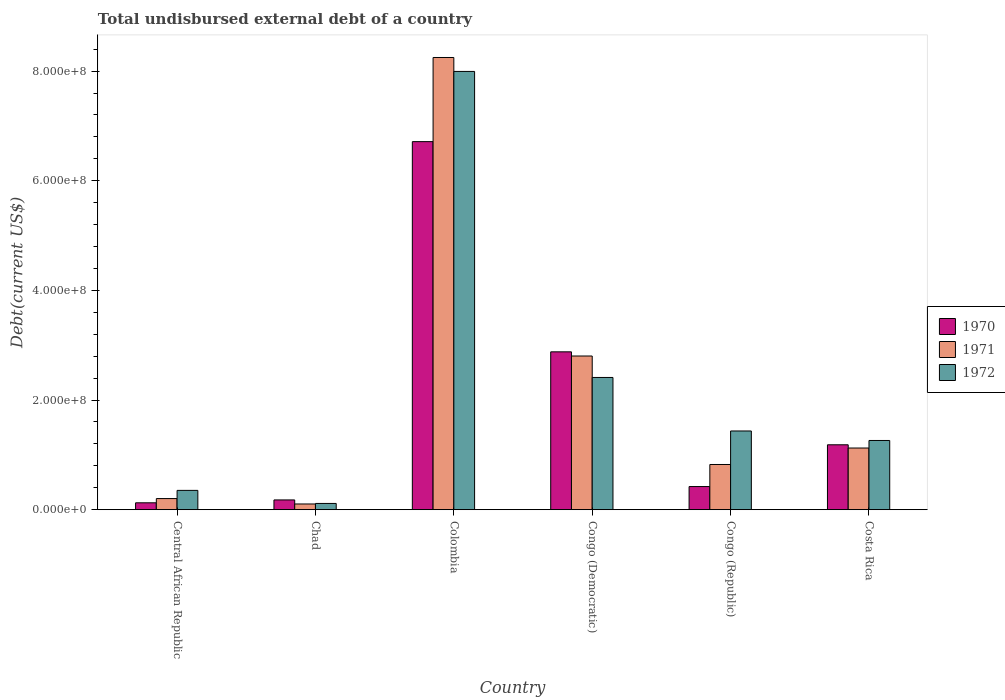Are the number of bars per tick equal to the number of legend labels?
Give a very brief answer. Yes. Are the number of bars on each tick of the X-axis equal?
Your response must be concise. Yes. How many bars are there on the 6th tick from the left?
Your answer should be very brief. 3. How many bars are there on the 6th tick from the right?
Offer a very short reply. 3. What is the label of the 5th group of bars from the left?
Provide a short and direct response. Congo (Republic). In how many cases, is the number of bars for a given country not equal to the number of legend labels?
Keep it short and to the point. 0. What is the total undisbursed external debt in 1972 in Congo (Democratic)?
Provide a succinct answer. 2.41e+08. Across all countries, what is the maximum total undisbursed external debt in 1970?
Ensure brevity in your answer.  6.71e+08. Across all countries, what is the minimum total undisbursed external debt in 1972?
Give a very brief answer. 1.14e+07. In which country was the total undisbursed external debt in 1972 maximum?
Offer a terse response. Colombia. In which country was the total undisbursed external debt in 1971 minimum?
Keep it short and to the point. Chad. What is the total total undisbursed external debt in 1970 in the graph?
Provide a short and direct response. 1.15e+09. What is the difference between the total undisbursed external debt in 1972 in Central African Republic and that in Chad?
Give a very brief answer. 2.38e+07. What is the difference between the total undisbursed external debt in 1972 in Congo (Democratic) and the total undisbursed external debt in 1970 in Costa Rica?
Make the answer very short. 1.23e+08. What is the average total undisbursed external debt in 1971 per country?
Make the answer very short. 2.22e+08. What is the difference between the total undisbursed external debt of/in 1971 and total undisbursed external debt of/in 1972 in Costa Rica?
Ensure brevity in your answer.  -1.38e+07. What is the ratio of the total undisbursed external debt in 1970 in Congo (Republic) to that in Costa Rica?
Your answer should be very brief. 0.36. Is the total undisbursed external debt in 1972 in Central African Republic less than that in Colombia?
Offer a terse response. Yes. Is the difference between the total undisbursed external debt in 1971 in Central African Republic and Congo (Republic) greater than the difference between the total undisbursed external debt in 1972 in Central African Republic and Congo (Republic)?
Make the answer very short. Yes. What is the difference between the highest and the second highest total undisbursed external debt in 1971?
Make the answer very short. 7.12e+08. What is the difference between the highest and the lowest total undisbursed external debt in 1971?
Ensure brevity in your answer.  8.14e+08. How many bars are there?
Make the answer very short. 18. Are all the bars in the graph horizontal?
Your answer should be compact. No. Does the graph contain grids?
Your answer should be compact. No. How many legend labels are there?
Your response must be concise. 3. How are the legend labels stacked?
Offer a terse response. Vertical. What is the title of the graph?
Your answer should be compact. Total undisbursed external debt of a country. What is the label or title of the Y-axis?
Ensure brevity in your answer.  Debt(current US$). What is the Debt(current US$) of 1970 in Central African Republic?
Ensure brevity in your answer.  1.26e+07. What is the Debt(current US$) of 1971 in Central African Republic?
Keep it short and to the point. 2.03e+07. What is the Debt(current US$) of 1972 in Central African Republic?
Provide a succinct answer. 3.52e+07. What is the Debt(current US$) of 1970 in Chad?
Give a very brief answer. 1.78e+07. What is the Debt(current US$) of 1971 in Chad?
Give a very brief answer. 1.04e+07. What is the Debt(current US$) in 1972 in Chad?
Your response must be concise. 1.14e+07. What is the Debt(current US$) in 1970 in Colombia?
Your answer should be compact. 6.71e+08. What is the Debt(current US$) of 1971 in Colombia?
Provide a short and direct response. 8.25e+08. What is the Debt(current US$) of 1972 in Colombia?
Provide a succinct answer. 7.99e+08. What is the Debt(current US$) of 1970 in Congo (Democratic)?
Offer a very short reply. 2.88e+08. What is the Debt(current US$) of 1971 in Congo (Democratic)?
Offer a terse response. 2.80e+08. What is the Debt(current US$) in 1972 in Congo (Democratic)?
Give a very brief answer. 2.41e+08. What is the Debt(current US$) of 1970 in Congo (Republic)?
Your answer should be compact. 4.22e+07. What is the Debt(current US$) of 1971 in Congo (Republic)?
Make the answer very short. 8.24e+07. What is the Debt(current US$) in 1972 in Congo (Republic)?
Ensure brevity in your answer.  1.44e+08. What is the Debt(current US$) in 1970 in Costa Rica?
Provide a short and direct response. 1.18e+08. What is the Debt(current US$) of 1971 in Costa Rica?
Provide a succinct answer. 1.12e+08. What is the Debt(current US$) of 1972 in Costa Rica?
Ensure brevity in your answer.  1.26e+08. Across all countries, what is the maximum Debt(current US$) in 1970?
Provide a succinct answer. 6.71e+08. Across all countries, what is the maximum Debt(current US$) of 1971?
Make the answer very short. 8.25e+08. Across all countries, what is the maximum Debt(current US$) in 1972?
Ensure brevity in your answer.  7.99e+08. Across all countries, what is the minimum Debt(current US$) of 1970?
Offer a terse response. 1.26e+07. Across all countries, what is the minimum Debt(current US$) in 1971?
Make the answer very short. 1.04e+07. Across all countries, what is the minimum Debt(current US$) in 1972?
Keep it short and to the point. 1.14e+07. What is the total Debt(current US$) in 1970 in the graph?
Make the answer very short. 1.15e+09. What is the total Debt(current US$) of 1971 in the graph?
Make the answer very short. 1.33e+09. What is the total Debt(current US$) of 1972 in the graph?
Ensure brevity in your answer.  1.36e+09. What is the difference between the Debt(current US$) in 1970 in Central African Republic and that in Chad?
Your response must be concise. -5.25e+06. What is the difference between the Debt(current US$) of 1971 in Central African Republic and that in Chad?
Make the answer very short. 9.88e+06. What is the difference between the Debt(current US$) of 1972 in Central African Republic and that in Chad?
Keep it short and to the point. 2.38e+07. What is the difference between the Debt(current US$) in 1970 in Central African Republic and that in Colombia?
Keep it short and to the point. -6.59e+08. What is the difference between the Debt(current US$) in 1971 in Central African Republic and that in Colombia?
Make the answer very short. -8.05e+08. What is the difference between the Debt(current US$) in 1972 in Central African Republic and that in Colombia?
Ensure brevity in your answer.  -7.64e+08. What is the difference between the Debt(current US$) in 1970 in Central African Republic and that in Congo (Democratic)?
Your response must be concise. -2.75e+08. What is the difference between the Debt(current US$) in 1971 in Central African Republic and that in Congo (Democratic)?
Offer a very short reply. -2.60e+08. What is the difference between the Debt(current US$) in 1972 in Central African Republic and that in Congo (Democratic)?
Make the answer very short. -2.06e+08. What is the difference between the Debt(current US$) in 1970 in Central African Republic and that in Congo (Republic)?
Offer a very short reply. -2.96e+07. What is the difference between the Debt(current US$) in 1971 in Central African Republic and that in Congo (Republic)?
Provide a succinct answer. -6.21e+07. What is the difference between the Debt(current US$) of 1972 in Central African Republic and that in Congo (Republic)?
Provide a succinct answer. -1.08e+08. What is the difference between the Debt(current US$) of 1970 in Central African Republic and that in Costa Rica?
Keep it short and to the point. -1.06e+08. What is the difference between the Debt(current US$) of 1971 in Central African Republic and that in Costa Rica?
Your answer should be compact. -9.22e+07. What is the difference between the Debt(current US$) of 1972 in Central African Republic and that in Costa Rica?
Provide a succinct answer. -9.10e+07. What is the difference between the Debt(current US$) of 1970 in Chad and that in Colombia?
Make the answer very short. -6.54e+08. What is the difference between the Debt(current US$) of 1971 in Chad and that in Colombia?
Give a very brief answer. -8.14e+08. What is the difference between the Debt(current US$) of 1972 in Chad and that in Colombia?
Offer a very short reply. -7.88e+08. What is the difference between the Debt(current US$) of 1970 in Chad and that in Congo (Democratic)?
Ensure brevity in your answer.  -2.70e+08. What is the difference between the Debt(current US$) of 1971 in Chad and that in Congo (Democratic)?
Provide a succinct answer. -2.70e+08. What is the difference between the Debt(current US$) in 1972 in Chad and that in Congo (Democratic)?
Offer a terse response. -2.30e+08. What is the difference between the Debt(current US$) in 1970 in Chad and that in Congo (Republic)?
Make the answer very short. -2.44e+07. What is the difference between the Debt(current US$) of 1971 in Chad and that in Congo (Republic)?
Provide a succinct answer. -7.20e+07. What is the difference between the Debt(current US$) of 1972 in Chad and that in Congo (Republic)?
Your answer should be very brief. -1.32e+08. What is the difference between the Debt(current US$) of 1970 in Chad and that in Costa Rica?
Ensure brevity in your answer.  -1.01e+08. What is the difference between the Debt(current US$) in 1971 in Chad and that in Costa Rica?
Provide a succinct answer. -1.02e+08. What is the difference between the Debt(current US$) in 1972 in Chad and that in Costa Rica?
Your answer should be very brief. -1.15e+08. What is the difference between the Debt(current US$) in 1970 in Colombia and that in Congo (Democratic)?
Your answer should be very brief. 3.83e+08. What is the difference between the Debt(current US$) of 1971 in Colombia and that in Congo (Democratic)?
Keep it short and to the point. 5.45e+08. What is the difference between the Debt(current US$) in 1972 in Colombia and that in Congo (Democratic)?
Your answer should be very brief. 5.58e+08. What is the difference between the Debt(current US$) of 1970 in Colombia and that in Congo (Republic)?
Provide a short and direct response. 6.29e+08. What is the difference between the Debt(current US$) in 1971 in Colombia and that in Congo (Republic)?
Ensure brevity in your answer.  7.42e+08. What is the difference between the Debt(current US$) in 1972 in Colombia and that in Congo (Republic)?
Ensure brevity in your answer.  6.56e+08. What is the difference between the Debt(current US$) of 1970 in Colombia and that in Costa Rica?
Your answer should be very brief. 5.53e+08. What is the difference between the Debt(current US$) of 1971 in Colombia and that in Costa Rica?
Ensure brevity in your answer.  7.12e+08. What is the difference between the Debt(current US$) in 1972 in Colombia and that in Costa Rica?
Offer a terse response. 6.73e+08. What is the difference between the Debt(current US$) in 1970 in Congo (Democratic) and that in Congo (Republic)?
Make the answer very short. 2.46e+08. What is the difference between the Debt(current US$) in 1971 in Congo (Democratic) and that in Congo (Republic)?
Your answer should be compact. 1.98e+08. What is the difference between the Debt(current US$) of 1972 in Congo (Democratic) and that in Congo (Republic)?
Your response must be concise. 9.76e+07. What is the difference between the Debt(current US$) in 1970 in Congo (Democratic) and that in Costa Rica?
Your answer should be very brief. 1.70e+08. What is the difference between the Debt(current US$) of 1971 in Congo (Democratic) and that in Costa Rica?
Make the answer very short. 1.68e+08. What is the difference between the Debt(current US$) of 1972 in Congo (Democratic) and that in Costa Rica?
Your answer should be compact. 1.15e+08. What is the difference between the Debt(current US$) of 1970 in Congo (Republic) and that in Costa Rica?
Your answer should be very brief. -7.62e+07. What is the difference between the Debt(current US$) in 1971 in Congo (Republic) and that in Costa Rica?
Your response must be concise. -3.00e+07. What is the difference between the Debt(current US$) in 1972 in Congo (Republic) and that in Costa Rica?
Keep it short and to the point. 1.73e+07. What is the difference between the Debt(current US$) in 1970 in Central African Republic and the Debt(current US$) in 1971 in Chad?
Offer a terse response. 2.13e+06. What is the difference between the Debt(current US$) in 1970 in Central African Republic and the Debt(current US$) in 1972 in Chad?
Give a very brief answer. 1.15e+06. What is the difference between the Debt(current US$) of 1971 in Central African Republic and the Debt(current US$) of 1972 in Chad?
Offer a very short reply. 8.90e+06. What is the difference between the Debt(current US$) in 1970 in Central African Republic and the Debt(current US$) in 1971 in Colombia?
Provide a succinct answer. -8.12e+08. What is the difference between the Debt(current US$) of 1970 in Central African Republic and the Debt(current US$) of 1972 in Colombia?
Provide a short and direct response. -7.87e+08. What is the difference between the Debt(current US$) of 1971 in Central African Republic and the Debt(current US$) of 1972 in Colombia?
Give a very brief answer. -7.79e+08. What is the difference between the Debt(current US$) in 1970 in Central African Republic and the Debt(current US$) in 1971 in Congo (Democratic)?
Keep it short and to the point. -2.68e+08. What is the difference between the Debt(current US$) in 1970 in Central African Republic and the Debt(current US$) in 1972 in Congo (Democratic)?
Your answer should be compact. -2.29e+08. What is the difference between the Debt(current US$) in 1971 in Central African Republic and the Debt(current US$) in 1972 in Congo (Democratic)?
Provide a short and direct response. -2.21e+08. What is the difference between the Debt(current US$) in 1970 in Central African Republic and the Debt(current US$) in 1971 in Congo (Republic)?
Your response must be concise. -6.99e+07. What is the difference between the Debt(current US$) in 1970 in Central African Republic and the Debt(current US$) in 1972 in Congo (Republic)?
Keep it short and to the point. -1.31e+08. What is the difference between the Debt(current US$) in 1971 in Central African Republic and the Debt(current US$) in 1972 in Congo (Republic)?
Keep it short and to the point. -1.23e+08. What is the difference between the Debt(current US$) of 1970 in Central African Republic and the Debt(current US$) of 1971 in Costa Rica?
Offer a very short reply. -9.99e+07. What is the difference between the Debt(current US$) in 1970 in Central African Republic and the Debt(current US$) in 1972 in Costa Rica?
Give a very brief answer. -1.14e+08. What is the difference between the Debt(current US$) of 1971 in Central African Republic and the Debt(current US$) of 1972 in Costa Rica?
Your answer should be very brief. -1.06e+08. What is the difference between the Debt(current US$) of 1970 in Chad and the Debt(current US$) of 1971 in Colombia?
Give a very brief answer. -8.07e+08. What is the difference between the Debt(current US$) of 1970 in Chad and the Debt(current US$) of 1972 in Colombia?
Give a very brief answer. -7.82e+08. What is the difference between the Debt(current US$) of 1971 in Chad and the Debt(current US$) of 1972 in Colombia?
Offer a terse response. -7.89e+08. What is the difference between the Debt(current US$) in 1970 in Chad and the Debt(current US$) in 1971 in Congo (Democratic)?
Ensure brevity in your answer.  -2.63e+08. What is the difference between the Debt(current US$) of 1970 in Chad and the Debt(current US$) of 1972 in Congo (Democratic)?
Keep it short and to the point. -2.23e+08. What is the difference between the Debt(current US$) in 1971 in Chad and the Debt(current US$) in 1972 in Congo (Democratic)?
Make the answer very short. -2.31e+08. What is the difference between the Debt(current US$) in 1970 in Chad and the Debt(current US$) in 1971 in Congo (Republic)?
Provide a short and direct response. -6.46e+07. What is the difference between the Debt(current US$) of 1970 in Chad and the Debt(current US$) of 1972 in Congo (Republic)?
Your response must be concise. -1.26e+08. What is the difference between the Debt(current US$) in 1971 in Chad and the Debt(current US$) in 1972 in Congo (Republic)?
Your response must be concise. -1.33e+08. What is the difference between the Debt(current US$) in 1970 in Chad and the Debt(current US$) in 1971 in Costa Rica?
Give a very brief answer. -9.47e+07. What is the difference between the Debt(current US$) of 1970 in Chad and the Debt(current US$) of 1972 in Costa Rica?
Make the answer very short. -1.08e+08. What is the difference between the Debt(current US$) of 1971 in Chad and the Debt(current US$) of 1972 in Costa Rica?
Offer a very short reply. -1.16e+08. What is the difference between the Debt(current US$) in 1970 in Colombia and the Debt(current US$) in 1971 in Congo (Democratic)?
Make the answer very short. 3.91e+08. What is the difference between the Debt(current US$) in 1970 in Colombia and the Debt(current US$) in 1972 in Congo (Democratic)?
Keep it short and to the point. 4.30e+08. What is the difference between the Debt(current US$) of 1971 in Colombia and the Debt(current US$) of 1972 in Congo (Democratic)?
Ensure brevity in your answer.  5.84e+08. What is the difference between the Debt(current US$) of 1970 in Colombia and the Debt(current US$) of 1971 in Congo (Republic)?
Ensure brevity in your answer.  5.89e+08. What is the difference between the Debt(current US$) in 1970 in Colombia and the Debt(current US$) in 1972 in Congo (Republic)?
Your answer should be compact. 5.28e+08. What is the difference between the Debt(current US$) in 1971 in Colombia and the Debt(current US$) in 1972 in Congo (Republic)?
Your response must be concise. 6.81e+08. What is the difference between the Debt(current US$) in 1970 in Colombia and the Debt(current US$) in 1971 in Costa Rica?
Provide a short and direct response. 5.59e+08. What is the difference between the Debt(current US$) in 1970 in Colombia and the Debt(current US$) in 1972 in Costa Rica?
Provide a short and direct response. 5.45e+08. What is the difference between the Debt(current US$) of 1971 in Colombia and the Debt(current US$) of 1972 in Costa Rica?
Offer a terse response. 6.99e+08. What is the difference between the Debt(current US$) in 1970 in Congo (Democratic) and the Debt(current US$) in 1971 in Congo (Republic)?
Make the answer very short. 2.06e+08. What is the difference between the Debt(current US$) in 1970 in Congo (Democratic) and the Debt(current US$) in 1972 in Congo (Republic)?
Keep it short and to the point. 1.44e+08. What is the difference between the Debt(current US$) in 1971 in Congo (Democratic) and the Debt(current US$) in 1972 in Congo (Republic)?
Keep it short and to the point. 1.37e+08. What is the difference between the Debt(current US$) in 1970 in Congo (Democratic) and the Debt(current US$) in 1971 in Costa Rica?
Provide a short and direct response. 1.75e+08. What is the difference between the Debt(current US$) of 1970 in Congo (Democratic) and the Debt(current US$) of 1972 in Costa Rica?
Make the answer very short. 1.62e+08. What is the difference between the Debt(current US$) of 1971 in Congo (Democratic) and the Debt(current US$) of 1972 in Costa Rica?
Your response must be concise. 1.54e+08. What is the difference between the Debt(current US$) of 1970 in Congo (Republic) and the Debt(current US$) of 1971 in Costa Rica?
Your response must be concise. -7.03e+07. What is the difference between the Debt(current US$) in 1970 in Congo (Republic) and the Debt(current US$) in 1972 in Costa Rica?
Your answer should be compact. -8.41e+07. What is the difference between the Debt(current US$) in 1971 in Congo (Republic) and the Debt(current US$) in 1972 in Costa Rica?
Provide a succinct answer. -4.38e+07. What is the average Debt(current US$) in 1970 per country?
Ensure brevity in your answer.  1.92e+08. What is the average Debt(current US$) in 1971 per country?
Your answer should be very brief. 2.22e+08. What is the average Debt(current US$) in 1972 per country?
Provide a short and direct response. 2.26e+08. What is the difference between the Debt(current US$) of 1970 and Debt(current US$) of 1971 in Central African Republic?
Keep it short and to the point. -7.74e+06. What is the difference between the Debt(current US$) in 1970 and Debt(current US$) in 1972 in Central African Republic?
Your answer should be very brief. -2.27e+07. What is the difference between the Debt(current US$) in 1971 and Debt(current US$) in 1972 in Central African Republic?
Keep it short and to the point. -1.49e+07. What is the difference between the Debt(current US$) of 1970 and Debt(current US$) of 1971 in Chad?
Provide a short and direct response. 7.38e+06. What is the difference between the Debt(current US$) in 1970 and Debt(current US$) in 1972 in Chad?
Your answer should be very brief. 6.41e+06. What is the difference between the Debt(current US$) of 1971 and Debt(current US$) of 1972 in Chad?
Provide a short and direct response. -9.77e+05. What is the difference between the Debt(current US$) in 1970 and Debt(current US$) in 1971 in Colombia?
Provide a succinct answer. -1.53e+08. What is the difference between the Debt(current US$) in 1970 and Debt(current US$) in 1972 in Colombia?
Your answer should be compact. -1.28e+08. What is the difference between the Debt(current US$) of 1971 and Debt(current US$) of 1972 in Colombia?
Provide a short and direct response. 2.54e+07. What is the difference between the Debt(current US$) of 1970 and Debt(current US$) of 1971 in Congo (Democratic)?
Make the answer very short. 7.62e+06. What is the difference between the Debt(current US$) of 1970 and Debt(current US$) of 1972 in Congo (Democratic)?
Your response must be concise. 4.67e+07. What is the difference between the Debt(current US$) of 1971 and Debt(current US$) of 1972 in Congo (Democratic)?
Make the answer very short. 3.91e+07. What is the difference between the Debt(current US$) in 1970 and Debt(current US$) in 1971 in Congo (Republic)?
Keep it short and to the point. -4.02e+07. What is the difference between the Debt(current US$) in 1970 and Debt(current US$) in 1972 in Congo (Republic)?
Your response must be concise. -1.01e+08. What is the difference between the Debt(current US$) in 1971 and Debt(current US$) in 1972 in Congo (Republic)?
Provide a succinct answer. -6.11e+07. What is the difference between the Debt(current US$) of 1970 and Debt(current US$) of 1971 in Costa Rica?
Offer a terse response. 5.91e+06. What is the difference between the Debt(current US$) in 1970 and Debt(current US$) in 1972 in Costa Rica?
Your answer should be very brief. -7.86e+06. What is the difference between the Debt(current US$) of 1971 and Debt(current US$) of 1972 in Costa Rica?
Offer a very short reply. -1.38e+07. What is the ratio of the Debt(current US$) of 1970 in Central African Republic to that in Chad?
Keep it short and to the point. 0.71. What is the ratio of the Debt(current US$) in 1971 in Central African Republic to that in Chad?
Keep it short and to the point. 1.95. What is the ratio of the Debt(current US$) of 1972 in Central African Republic to that in Chad?
Your answer should be compact. 3.09. What is the ratio of the Debt(current US$) in 1970 in Central African Republic to that in Colombia?
Provide a short and direct response. 0.02. What is the ratio of the Debt(current US$) of 1971 in Central African Republic to that in Colombia?
Offer a terse response. 0.02. What is the ratio of the Debt(current US$) of 1972 in Central African Republic to that in Colombia?
Ensure brevity in your answer.  0.04. What is the ratio of the Debt(current US$) of 1970 in Central African Republic to that in Congo (Democratic)?
Offer a terse response. 0.04. What is the ratio of the Debt(current US$) of 1971 in Central African Republic to that in Congo (Democratic)?
Make the answer very short. 0.07. What is the ratio of the Debt(current US$) in 1972 in Central African Republic to that in Congo (Democratic)?
Offer a very short reply. 0.15. What is the ratio of the Debt(current US$) of 1970 in Central African Republic to that in Congo (Republic)?
Your answer should be very brief. 0.3. What is the ratio of the Debt(current US$) of 1971 in Central African Republic to that in Congo (Republic)?
Your answer should be compact. 0.25. What is the ratio of the Debt(current US$) of 1972 in Central African Republic to that in Congo (Republic)?
Your response must be concise. 0.25. What is the ratio of the Debt(current US$) in 1970 in Central African Republic to that in Costa Rica?
Offer a very short reply. 0.11. What is the ratio of the Debt(current US$) of 1971 in Central African Republic to that in Costa Rica?
Make the answer very short. 0.18. What is the ratio of the Debt(current US$) in 1972 in Central African Republic to that in Costa Rica?
Provide a short and direct response. 0.28. What is the ratio of the Debt(current US$) of 1970 in Chad to that in Colombia?
Ensure brevity in your answer.  0.03. What is the ratio of the Debt(current US$) in 1971 in Chad to that in Colombia?
Ensure brevity in your answer.  0.01. What is the ratio of the Debt(current US$) of 1972 in Chad to that in Colombia?
Provide a succinct answer. 0.01. What is the ratio of the Debt(current US$) of 1970 in Chad to that in Congo (Democratic)?
Give a very brief answer. 0.06. What is the ratio of the Debt(current US$) of 1971 in Chad to that in Congo (Democratic)?
Offer a very short reply. 0.04. What is the ratio of the Debt(current US$) of 1972 in Chad to that in Congo (Democratic)?
Give a very brief answer. 0.05. What is the ratio of the Debt(current US$) in 1970 in Chad to that in Congo (Republic)?
Keep it short and to the point. 0.42. What is the ratio of the Debt(current US$) in 1971 in Chad to that in Congo (Republic)?
Ensure brevity in your answer.  0.13. What is the ratio of the Debt(current US$) of 1972 in Chad to that in Congo (Republic)?
Keep it short and to the point. 0.08. What is the ratio of the Debt(current US$) in 1970 in Chad to that in Costa Rica?
Your response must be concise. 0.15. What is the ratio of the Debt(current US$) in 1971 in Chad to that in Costa Rica?
Ensure brevity in your answer.  0.09. What is the ratio of the Debt(current US$) in 1972 in Chad to that in Costa Rica?
Your answer should be very brief. 0.09. What is the ratio of the Debt(current US$) of 1970 in Colombia to that in Congo (Democratic)?
Provide a succinct answer. 2.33. What is the ratio of the Debt(current US$) of 1971 in Colombia to that in Congo (Democratic)?
Give a very brief answer. 2.94. What is the ratio of the Debt(current US$) of 1972 in Colombia to that in Congo (Democratic)?
Provide a short and direct response. 3.31. What is the ratio of the Debt(current US$) of 1970 in Colombia to that in Congo (Republic)?
Offer a terse response. 15.91. What is the ratio of the Debt(current US$) in 1971 in Colombia to that in Congo (Republic)?
Offer a very short reply. 10. What is the ratio of the Debt(current US$) of 1972 in Colombia to that in Congo (Republic)?
Ensure brevity in your answer.  5.57. What is the ratio of the Debt(current US$) of 1970 in Colombia to that in Costa Rica?
Keep it short and to the point. 5.67. What is the ratio of the Debt(current US$) of 1971 in Colombia to that in Costa Rica?
Offer a terse response. 7.33. What is the ratio of the Debt(current US$) of 1972 in Colombia to that in Costa Rica?
Keep it short and to the point. 6.33. What is the ratio of the Debt(current US$) in 1970 in Congo (Democratic) to that in Congo (Republic)?
Provide a succinct answer. 6.82. What is the ratio of the Debt(current US$) of 1971 in Congo (Democratic) to that in Congo (Republic)?
Your answer should be compact. 3.4. What is the ratio of the Debt(current US$) of 1972 in Congo (Democratic) to that in Congo (Republic)?
Provide a short and direct response. 1.68. What is the ratio of the Debt(current US$) of 1970 in Congo (Democratic) to that in Costa Rica?
Offer a terse response. 2.43. What is the ratio of the Debt(current US$) in 1971 in Congo (Democratic) to that in Costa Rica?
Offer a very short reply. 2.49. What is the ratio of the Debt(current US$) of 1972 in Congo (Democratic) to that in Costa Rica?
Ensure brevity in your answer.  1.91. What is the ratio of the Debt(current US$) of 1970 in Congo (Republic) to that in Costa Rica?
Give a very brief answer. 0.36. What is the ratio of the Debt(current US$) of 1971 in Congo (Republic) to that in Costa Rica?
Provide a short and direct response. 0.73. What is the ratio of the Debt(current US$) of 1972 in Congo (Republic) to that in Costa Rica?
Offer a very short reply. 1.14. What is the difference between the highest and the second highest Debt(current US$) of 1970?
Give a very brief answer. 3.83e+08. What is the difference between the highest and the second highest Debt(current US$) of 1971?
Give a very brief answer. 5.45e+08. What is the difference between the highest and the second highest Debt(current US$) of 1972?
Offer a terse response. 5.58e+08. What is the difference between the highest and the lowest Debt(current US$) of 1970?
Your response must be concise. 6.59e+08. What is the difference between the highest and the lowest Debt(current US$) in 1971?
Offer a terse response. 8.14e+08. What is the difference between the highest and the lowest Debt(current US$) of 1972?
Offer a terse response. 7.88e+08. 